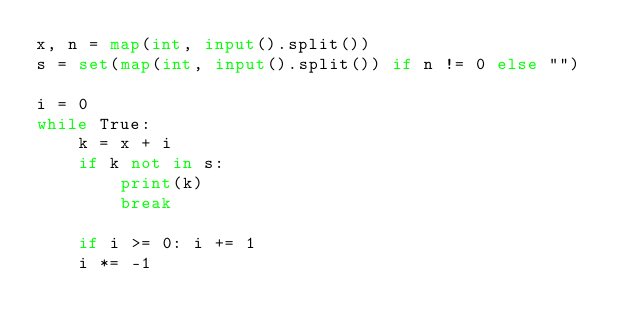Convert code to text. <code><loc_0><loc_0><loc_500><loc_500><_Python_>x, n = map(int, input().split())
s = set(map(int, input().split()) if n != 0 else "")

i = 0
while True:
    k = x + i
    if k not in s:
        print(k)
        break

    if i >= 0: i += 1
    i *= -1
</code> 